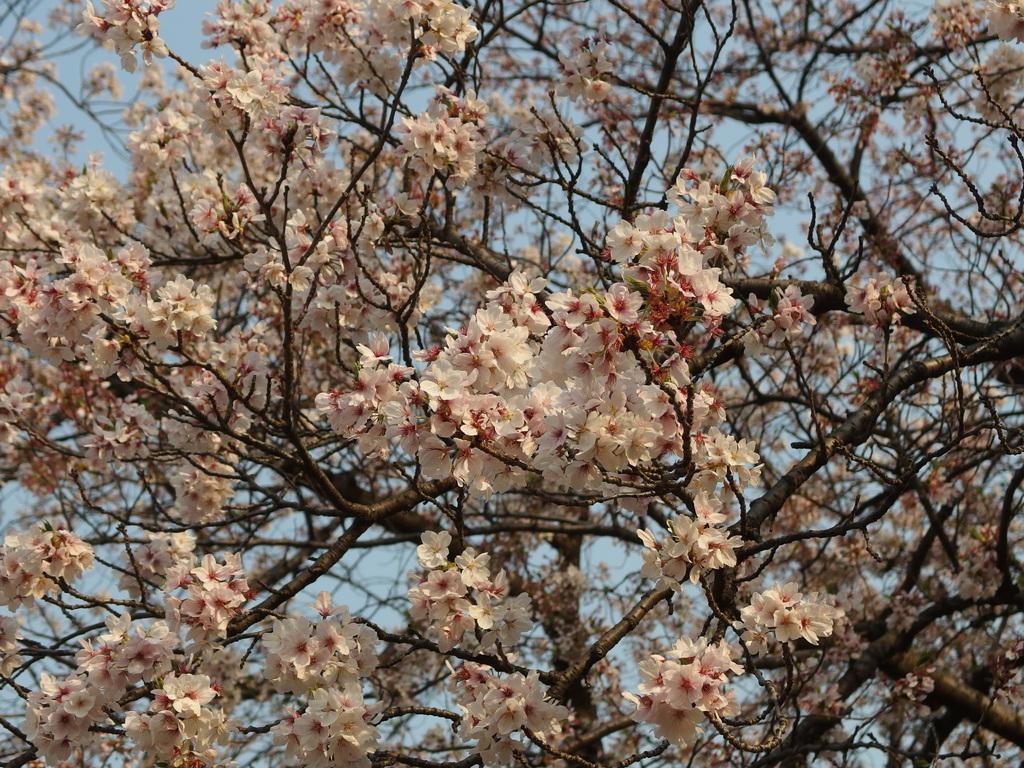Could you give a brief overview of what you see in this image? Here in this picture we can see a tree present over there and to that we can see white colored flowers present all over it. 